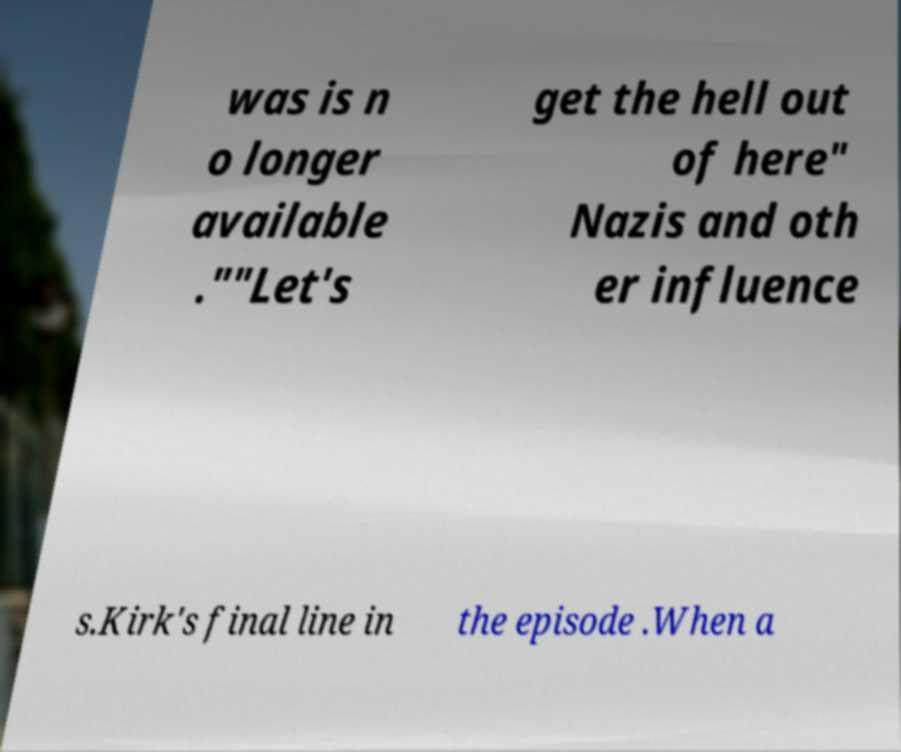Can you accurately transcribe the text from the provided image for me? was is n o longer available .""Let's get the hell out of here" Nazis and oth er influence s.Kirk's final line in the episode .When a 